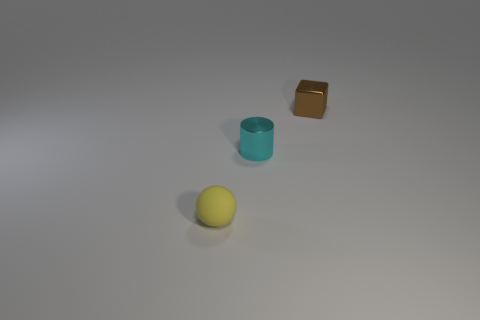Add 2 large purple rubber things. How many objects exist? 5 Subtract all cubes. How many objects are left? 2 Subtract all yellow balls. Subtract all big green shiny spheres. How many objects are left? 2 Add 2 tiny yellow rubber spheres. How many tiny yellow rubber spheres are left? 3 Add 3 tiny brown matte cylinders. How many tiny brown matte cylinders exist? 3 Subtract 0 purple cylinders. How many objects are left? 3 